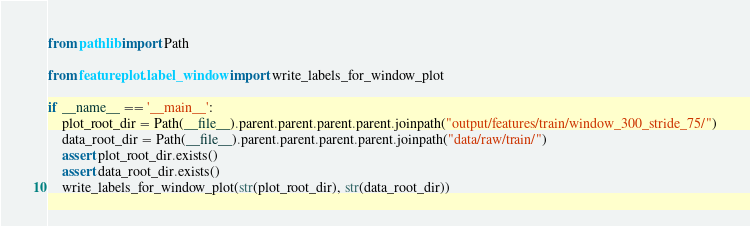<code> <loc_0><loc_0><loc_500><loc_500><_Python_>from pathlib import Path

from feature.plot.label_window import write_labels_for_window_plot

if __name__ == '__main__':
    plot_root_dir = Path(__file__).parent.parent.parent.parent.joinpath("output/features/train/window_300_stride_75/")
    data_root_dir = Path(__file__).parent.parent.parent.parent.joinpath("data/raw/train/")
    assert plot_root_dir.exists()
    assert data_root_dir.exists()
    write_labels_for_window_plot(str(plot_root_dir), str(data_root_dir))
</code> 